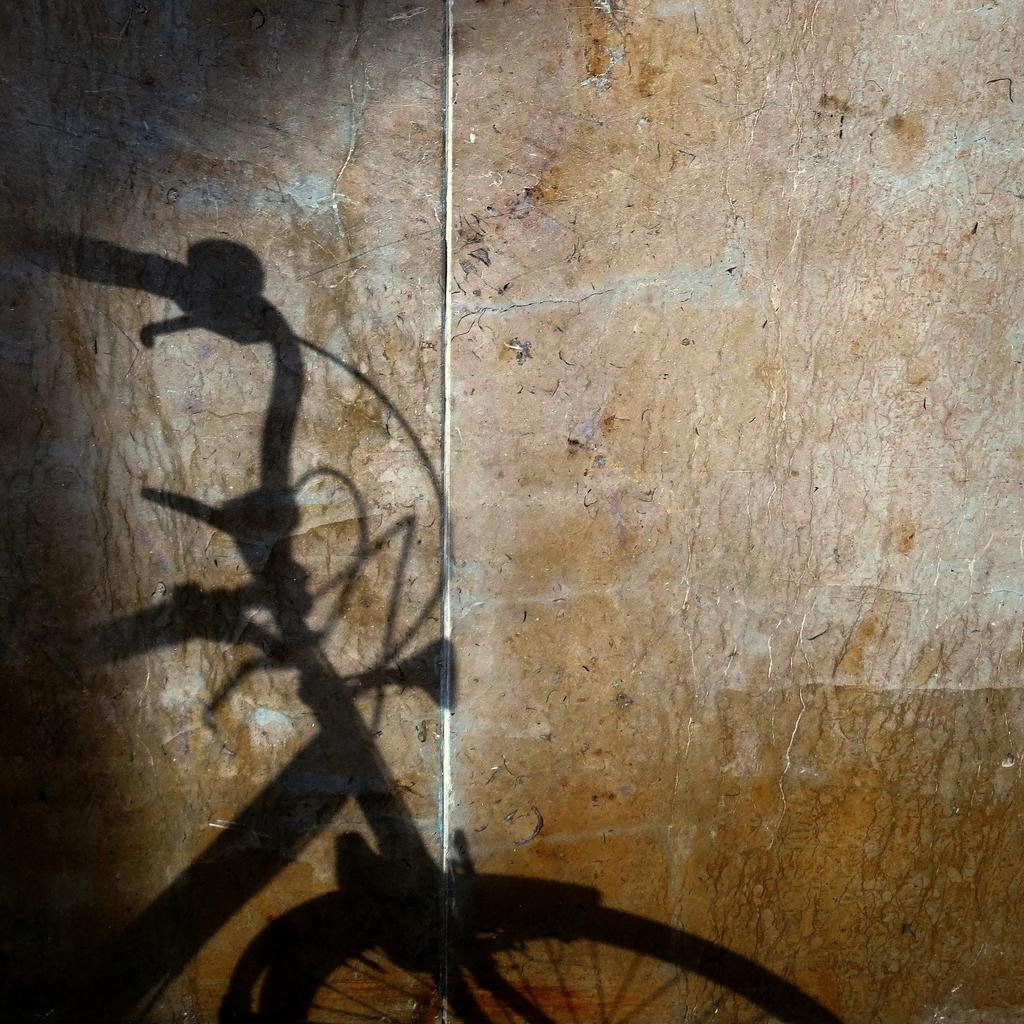What is the main subject of the image? The main subject of the image is a shadow of a bicycle. What month is it in the image? The provided facts do not mention any specific month, and the image only shows a shadow of a bicycle, so it is not possible to determine the month from the image. 